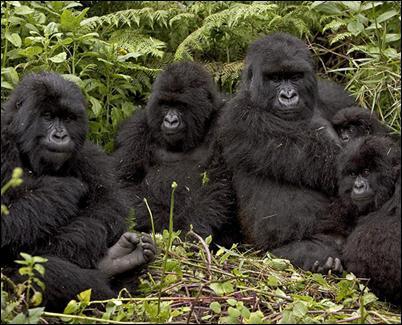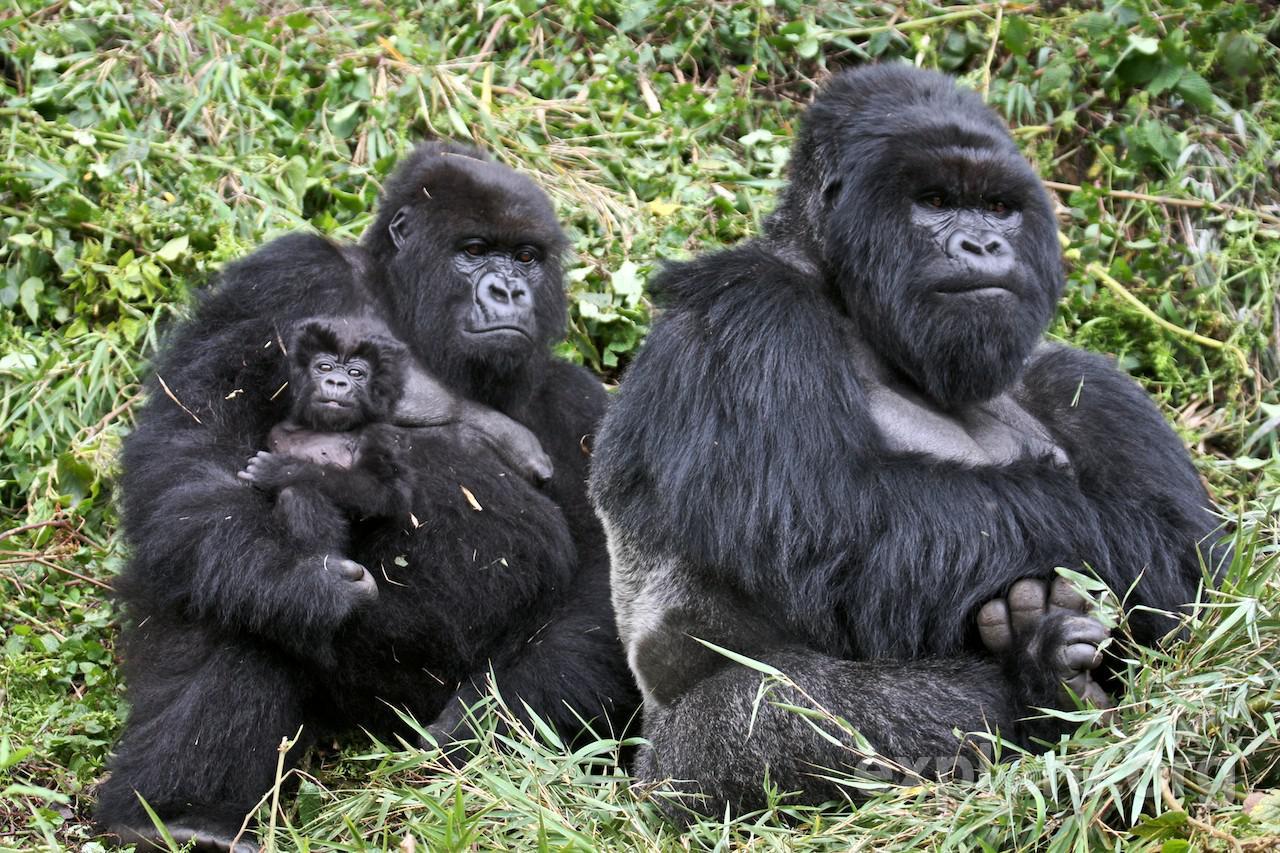The first image is the image on the left, the second image is the image on the right. Assess this claim about the two images: "The right image includes no more than two apes.". Correct or not? Answer yes or no. No. The first image is the image on the left, the second image is the image on the right. For the images displayed, is the sentence "Three gorillas sit in the grass in the image on the right." factually correct? Answer yes or no. Yes. 